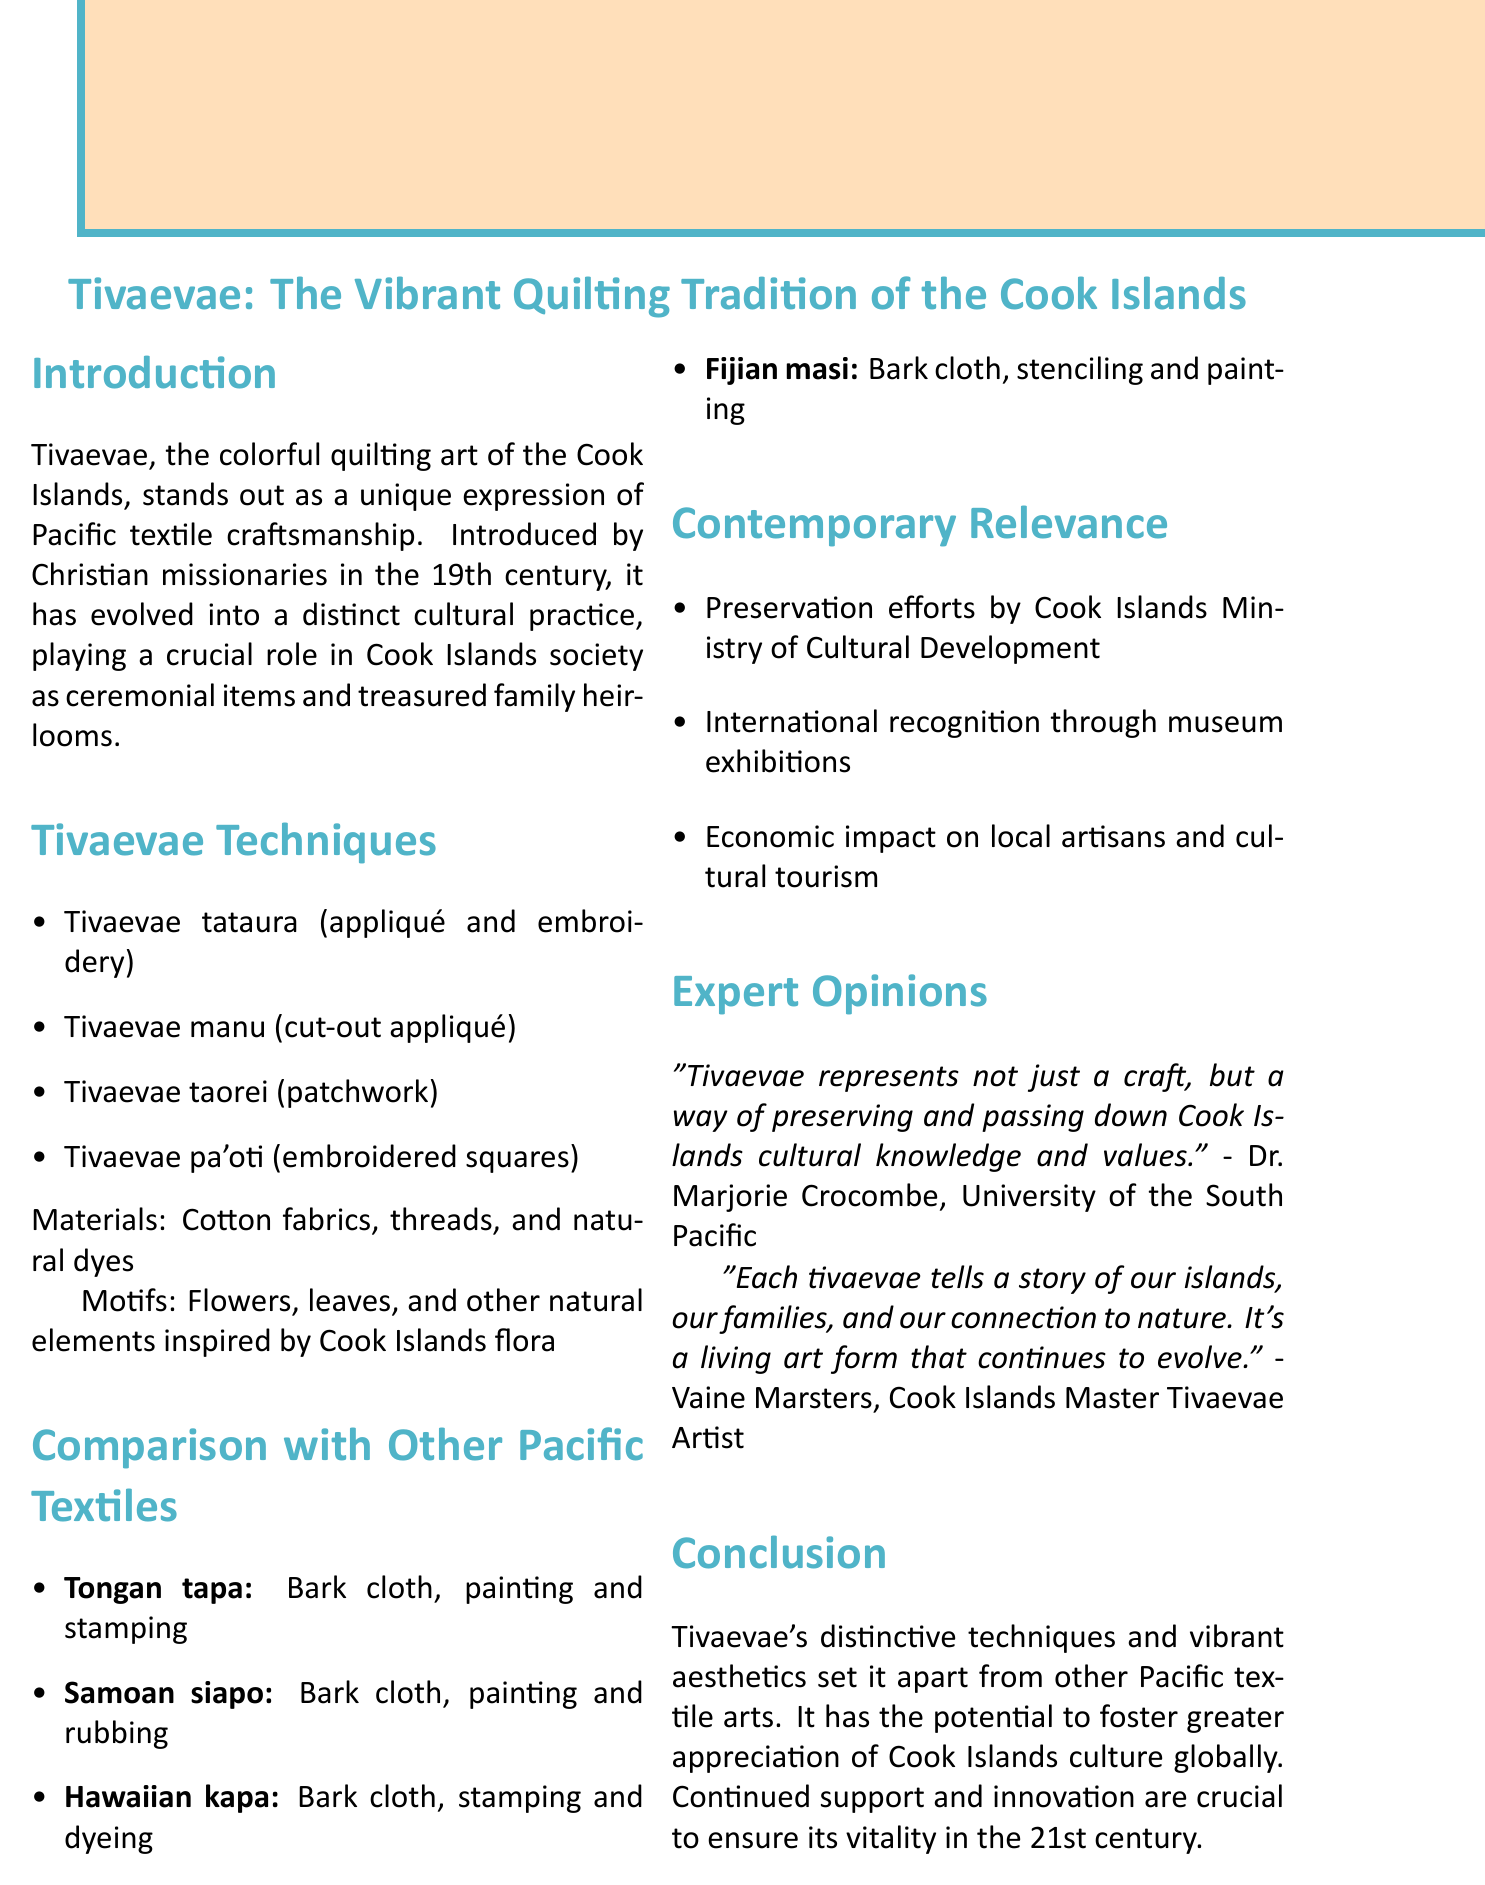What are the main types of tivaevae techniques? The document lists four primary types of tivaevae techniques, which include Tivaevae tataura, Tivaevae manu, Tivaevae taorei, and Tivaevae pa'oti.
Answer: Tivaevae tataura, Tivaevae manu, Tivaevae taorei, Tivaevae pa'oti Who introduced tivaevae to the Cook Islands? The introduction section of the document notes that Christian missionaries introduced tivaevae in the 19th century.
Answer: Christian missionaries What materials are used in tivaevae quilting? The document specifically mentions that cotton fabrics, threads, and natural dyes are the materials used in tivaevae quilting.
Answer: Cotton fabrics, threads, and natural dyes Which museum featured exhibitions of tivaevae? The contemporary relevance section states that tivaevae has been recognized through exhibitions at institutions such as Te Papa Tongarewa and the British Museum.
Answer: Te Papa Tongarewa, British Museum What is a common element in the motifs of tivaevae? The document describes that tivaevae motifs are inspired by natural elements, specifically recognized features from Cook Islands flora.
Answer: Flowers, leaves, and other natural elements How does tivaevae compare to Tongan tapa? According to the comparison section, both involve materials and techniques like painting and stamping, and share similarities such as geometric patterns and nature-inspired motifs.
Answer: Geometric patterns and nature-inspired motifs What does Dr. Marjorie Crocombe say about tivaevae? The document contains a quote from Dr. Crocombe highlighting the cultural significance of tivaevae as a means of preserving Cook Islands cultural knowledge and values.
Answer: A way of preserving and passing down Cook Islands cultural knowledge and values What is one future prospect for tivaevae mentioned in the conclusion? The document emphasizes the importance of continued support and innovation in tivaevae-making to ensure its vitality as a cultural practice in the 21st century.
Answer: Continued support and innovation in tivaevae-making 